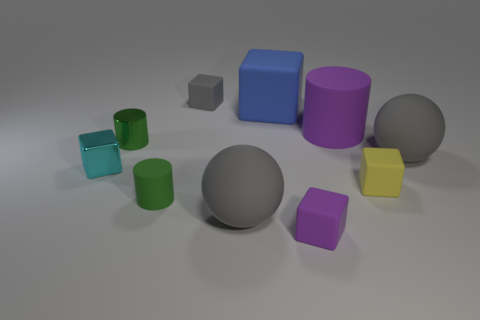Subtract all blue blocks. How many blocks are left? 4 Subtract 1 blocks. How many blocks are left? 4 Subtract all big cubes. How many cubes are left? 4 Subtract all brown blocks. Subtract all gray spheres. How many blocks are left? 5 Subtract all cylinders. How many objects are left? 7 Add 2 small cyan shiny blocks. How many small cyan shiny blocks are left? 3 Add 6 large purple rubber things. How many large purple rubber things exist? 7 Subtract 0 blue cylinders. How many objects are left? 10 Subtract all blue blocks. Subtract all gray cubes. How many objects are left? 8 